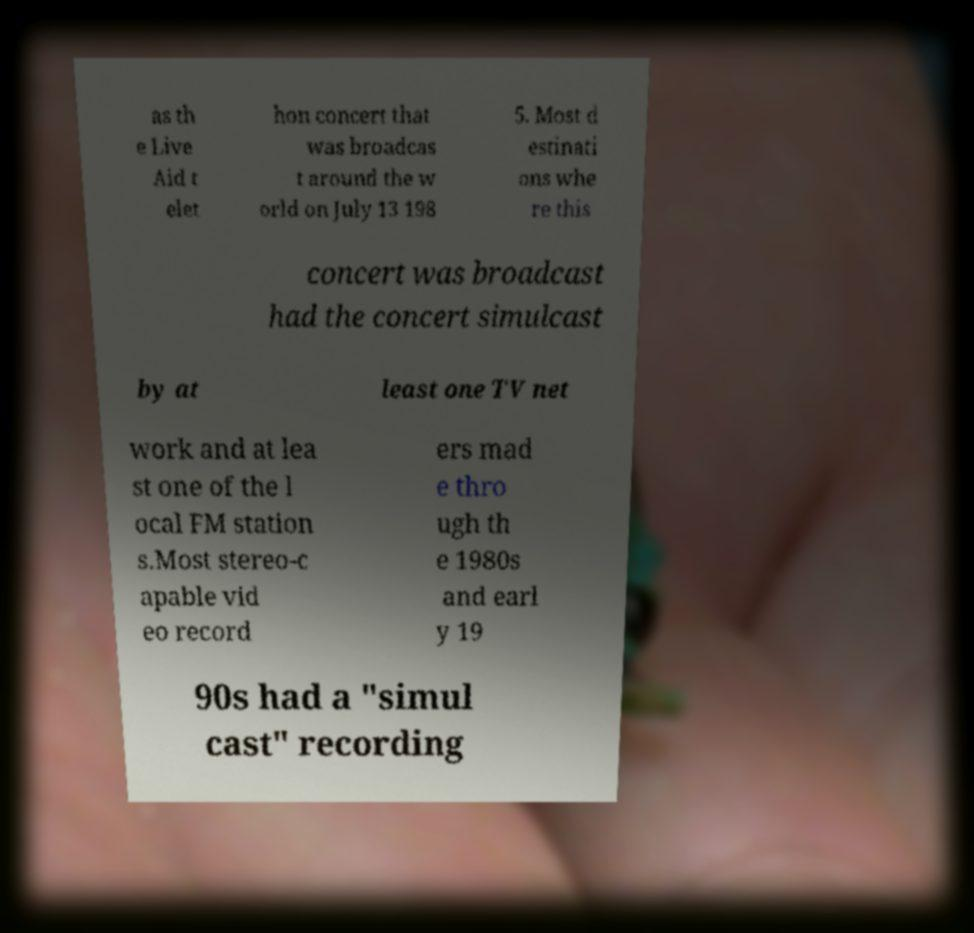Could you assist in decoding the text presented in this image and type it out clearly? as th e Live Aid t elet hon concert that was broadcas t around the w orld on July 13 198 5. Most d estinati ons whe re this concert was broadcast had the concert simulcast by at least one TV net work and at lea st one of the l ocal FM station s.Most stereo-c apable vid eo record ers mad e thro ugh th e 1980s and earl y 19 90s had a "simul cast" recording 